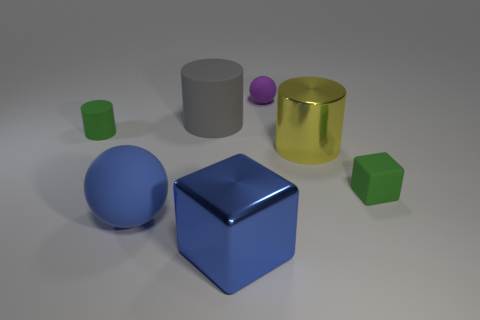What could be the context or setting of this image? The image appears to be a 3D rendering, possibly created for a visual arts project or a computer graphics demonstration. The focus seems to be on geometry and color, utilizing simple shapes and different colors to likely showcase rendering techniques or color contrasts within a controlled environment. 